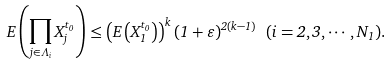Convert formula to latex. <formula><loc_0><loc_0><loc_500><loc_500>E \left ( \prod _ { j \in \Lambda _ { i } } X _ { j } ^ { t _ { 0 } } \right ) \leq \left ( E \left ( X _ { 1 } ^ { t _ { 0 } } \right ) \right ) ^ { k } ( 1 + \varepsilon ) ^ { 2 ( k - 1 ) } \ ( i = 2 , 3 , \cdots , N _ { 1 } ) .</formula> 